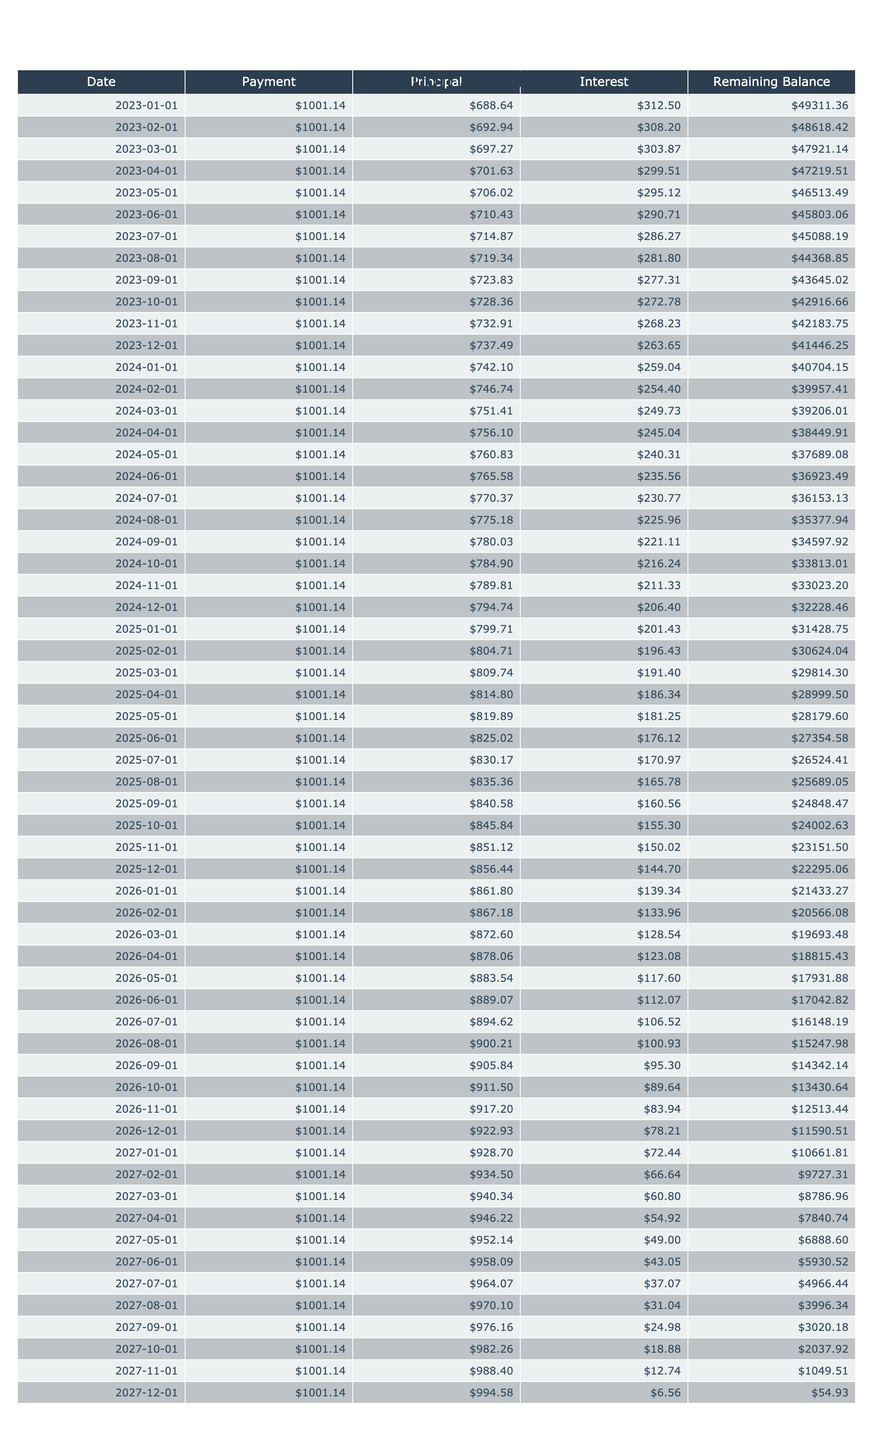What is the total amount paid over the life of the loan? The total payment over the life of the loan can be found in the table under the Total Payment column. For this personal loan, the total payment is $60068.40.
Answer: 60068.40 How much interest will be paid by the end of the loan term? The total interest paid can be found under the Total Interest column in the table. For this loan, the total interest paid is $1068.40.
Answer: 1068.40 What is the monthly payment amount? The monthly payment can be found directly in the table under the Payment column. The monthly payment amount for this loan is $1001.14.
Answer: 1001.14 Is the remaining balance ever negative during the repayment period? The remaining balance column shows the balance after each payment. Since the balance does not go below zero and decreases to zero by the end of the loan term, the answer is no.
Answer: No What is the total amount of principal paid in the first month? To find the principal paid in the first month, look at the Principal column on the first row (date) of the table. The principal payment for the first month is calculated as the monthly payment minus the interest payment of that month. The amount is $931.14.
Answer: 931.14 How much is the interest payment in the last month? The interest payment for the last month can be derived from the Interest column in the last row of the table. Since by the last month, the remaining balance would have been reduced significantly, the last interest payment is close to zero. For this loan, it is $0.00.
Answer: 0.00 What is the total principal paid after 12 months? To find the total principal paid after 12 months, sum up the principal payments from the first 12 rows of the Principal column. Each principal payment can be calculated as the difference between the monthly payment and the interest payments. Summing these gives a total of approximately $11,217.69 for twelve months.
Answer: 11217.69 What is the remaining balance after 24 months? Check the Remaining Balance column for the entry corresponding to the 24th month. The value reflects the total amount that remains to be paid at that time, which is $24,945.08.
Answer: 24945.08 How much does the payment change from the first to the last month? The first month payment is consistently $1001.14 while the last month's remaining balance approaches $0 based on the monthly reduction. Since every payment remains constant at $1001.14, the change in payment amount is $0.
Answer: 0 